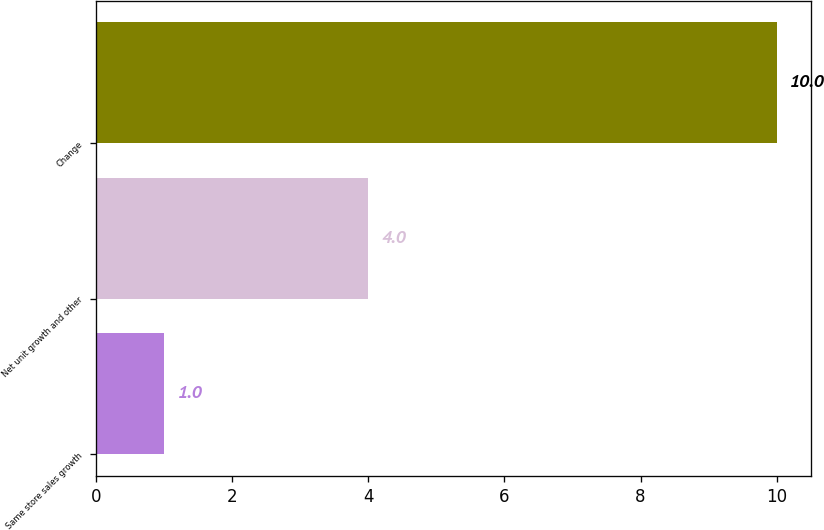<chart> <loc_0><loc_0><loc_500><loc_500><bar_chart><fcel>Same store sales growth<fcel>Net unit growth and other<fcel>Change<nl><fcel>1<fcel>4<fcel>10<nl></chart> 